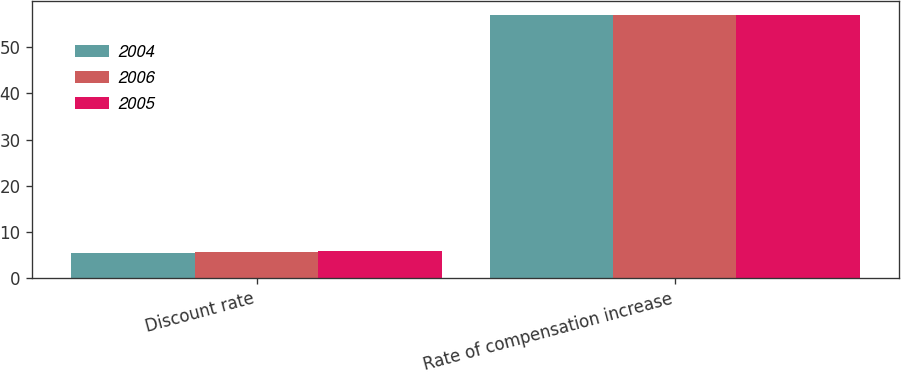<chart> <loc_0><loc_0><loc_500><loc_500><stacked_bar_chart><ecel><fcel>Discount rate<fcel>Rate of compensation increase<nl><fcel>2004<fcel>5.5<fcel>57<nl><fcel>2006<fcel>5.75<fcel>57<nl><fcel>2005<fcel>6<fcel>57<nl></chart> 